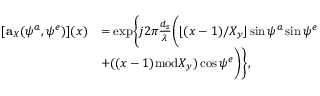Convert formula to latex. <formula><loc_0><loc_0><loc_500><loc_500>\begin{array} { r l } { [ a _ { X } ( \psi ^ { a } , \psi ^ { e } ) ] ( x ) } & { = { e x p } \left \{ j 2 \pi \frac { d _ { s } } { \lambda } \left ( \lfloor ( x - 1 ) / X _ { y } \rfloor \sin \psi ^ { a } \sin \psi ^ { e } } \\ & { + ( ( x - 1 ) { m o d } X _ { y } ) \cos \psi ^ { e } \right ) \right \} , } \end{array}</formula> 